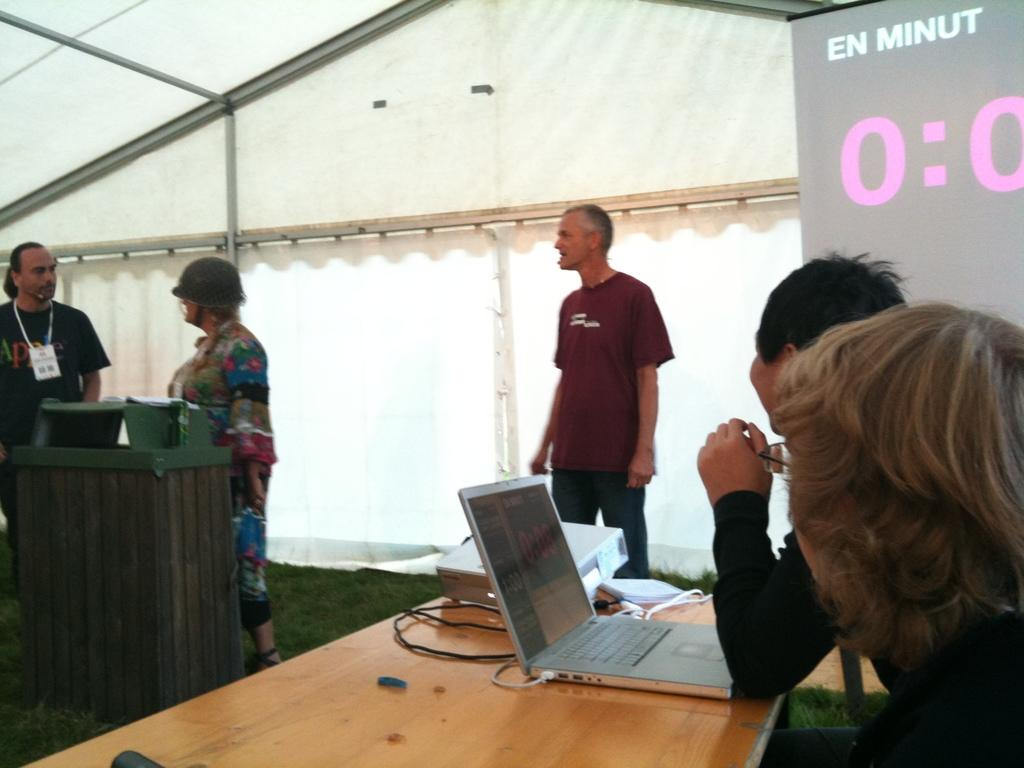What are the people in the image doing? Some people are standing, while others are seated on chairs in the image. What electronic device is visible in the image? There is a laptop visible in the image. What is the purpose of the projector screen in the image? The projector screen is likely used for displaying information or presentations. Where is the projector located in the image? The projector is on a table in the image. How many men are standing next to the tree in the image? There is no tree or men standing next to it in the image. What type of beggar can be seen in the image? There is no beggar present in the image. 